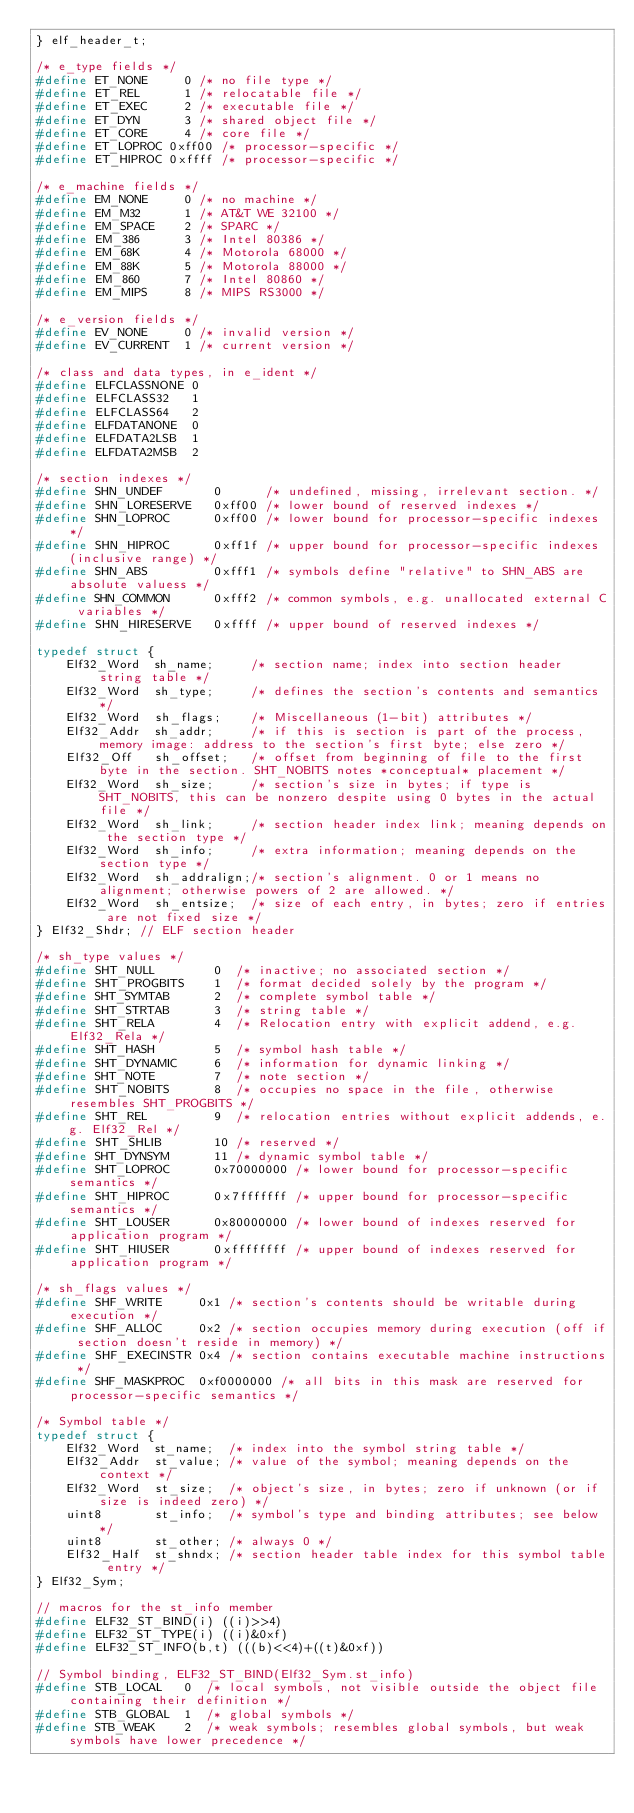<code> <loc_0><loc_0><loc_500><loc_500><_C_>} elf_header_t;

/* e_type fields */
#define ET_NONE		0 /* no file type */
#define ET_REL		1 /* relocatable file */
#define ET_EXEC		2 /* executable file */
#define ET_DYN		3 /* shared object file */
#define ET_CORE		4 /* core file */
#define ET_LOPROC 0xff00 /* processor-specific */
#define ET_HIPROC 0xffff /* processor-specific */

/* e_machine fields */
#define EM_NONE		0 /* no machine */
#define EM_M32		1 /* AT&T WE 32100 */
#define EM_SPACE	2 /* SPARC */
#define EM_386		3 /* Intel 80386 */
#define EM_68K		4 /* Motorola 68000 */
#define EM_88K		5 /* Motorola 88000 */
#define EM_860		7 /* Intel 80860 */
#define EM_MIPS		8 /* MIPS RS3000 */

/* e_version fields */
#define EV_NONE 	0 /* invalid version */
#define EV_CURRENT	1 /* current version */

/* class and data types, in e_ident */
#define ELFCLASSNONE 0
#define ELFCLASS32	 1
#define ELFCLASS64	 2
#define ELFDATANONE  0
#define ELFDATA2LSB	 1
#define ELFDATA2MSB	 2

/* section indexes */
#define SHN_UNDEF		0	   /* undefined, missing, irrelevant section. */
#define SHN_LORESERVE	0xff00 /* lower bound of reserved indexes */
#define SHN_LOPROC		0xff00 /* lower bound for processor-specific indexes */
#define SHN_HIPROC		0xff1f /* upper bound for processor-specific indexes (inclusive range) */
#define SHN_ABS			0xfff1 /* symbols define "relative" to SHN_ABS are absolute valuess */
#define SHN_COMMON		0xfff2 /* common symbols, e.g. unallocated external C variables */
#define SHN_HIRESERVE	0xffff /* upper bound of reserved indexes */

typedef struct {
	Elf32_Word	sh_name;	 /* section name; index into section header string table */
	Elf32_Word	sh_type;	 /* defines the section's contents and semantics */
	Elf32_Word	sh_flags;	 /* Miscellaneous (1-bit) attributes */
	Elf32_Addr 	sh_addr;	 /* if this is section is part of the process, memory image: address to the section's first byte; else zero */
	Elf32_Off	sh_offset;	 /* offset from beginning of file to the first byte in the section. SHT_NOBITS notes *conceptual* placement */
	Elf32_Word	sh_size;	 /* section's size in bytes; if type is SHT_NOBITS, this can be nonzero despite using 0 bytes in the actual file */
	Elf32_Word	sh_link;	 /* section header index link; meaning depends on the section type */
	Elf32_Word	sh_info;	 /* extra information; meaning depends on the section type */
	Elf32_Word	sh_addralign;/* section's alignment. 0 or 1 means no alignment; otherwise powers of 2 are allowed. */
	Elf32_Word	sh_entsize;	 /* size of each entry, in bytes; zero if entries are not fixed size */
} Elf32_Shdr; // ELF section header

/* sh_type values */
#define SHT_NULL		0  /* inactive; no associated section */
#define SHT_PROGBITS	1  /* format decided solely by the program */
#define SHT_SYMTAB		2  /* complete symbol table */
#define SHT_STRTAB		3  /* string table */
#define SHT_RELA		4  /* Relocation entry with explicit addend, e.g. Elf32_Rela */
#define SHT_HASH		5  /* symbol hash table */
#define SHT_DYNAMIC		6  /* information for dynamic linking */
#define SHT_NOTE		7  /* note section */
#define SHT_NOBITS		8  /* occupies no space in the file, otherwise resembles SHT_PROGBITS */
#define SHT_REL			9  /* relocation entries without explicit addends, e.g. Elf32_Rel */
#define SHT_SHLIB		10 /* reserved */
#define SHT_DYNSYM		11 /* dynamic symbol table */
#define SHT_LOPROC		0x70000000 /* lower bound for processor-specific semantics */
#define SHT_HIPROC		0x7fffffff /* upper bound for processor-specific semantics */
#define SHT_LOUSER		0x80000000 /* lower bound of indexes reserved for application program */
#define SHT_HIUSER		0xffffffff /* upper bound of indexes reserved for application program */

/* sh_flags values */
#define SHF_WRITE	  0x1 /* section's contents should be writable during execution */
#define SHF_ALLOC	  0x2 /* section occupies memory during execution (off if section doesn't reside in memory) */
#define SHF_EXECINSTR 0x4 /* section contains executable machine instructions */
#define SHF_MASKPROC  0xf0000000 /* all bits in this mask are reserved for processor-specific semantics */

/* Symbol table */
typedef struct {
	Elf32_Word	st_name;  /* index into the symbol string table */
	Elf32_Addr	st_value; /* value of the symbol; meaning depends on the context */
	Elf32_Word	st_size;  /* object's size, in bytes; zero if unknown (or if size is indeed zero) */
	uint8		st_info;  /* symbol's type and binding attributes; see below */
	uint8		st_other; /* always 0 */
	Elf32_Half	st_shndx; /* section header table index for this symbol table entry */
} Elf32_Sym;

// macros for the st_info member
#define ELF32_ST_BIND(i) ((i)>>4)
#define ELF32_ST_TYPE(i) ((i)&0xf)
#define ELF32_ST_INFO(b,t) (((b)<<4)+((t)&0xf))

// Symbol binding, ELF32_ST_BIND(Elf32_Sym.st_info)
#define STB_LOCAL	0  /* local symbols, not visible outside the object file containing their definition */
#define STB_GLOBAL	1  /* global symbols */
#define STB_WEAK	2  /* weak symbols; resembles global symbols, but weak symbols have lower precedence */</code> 